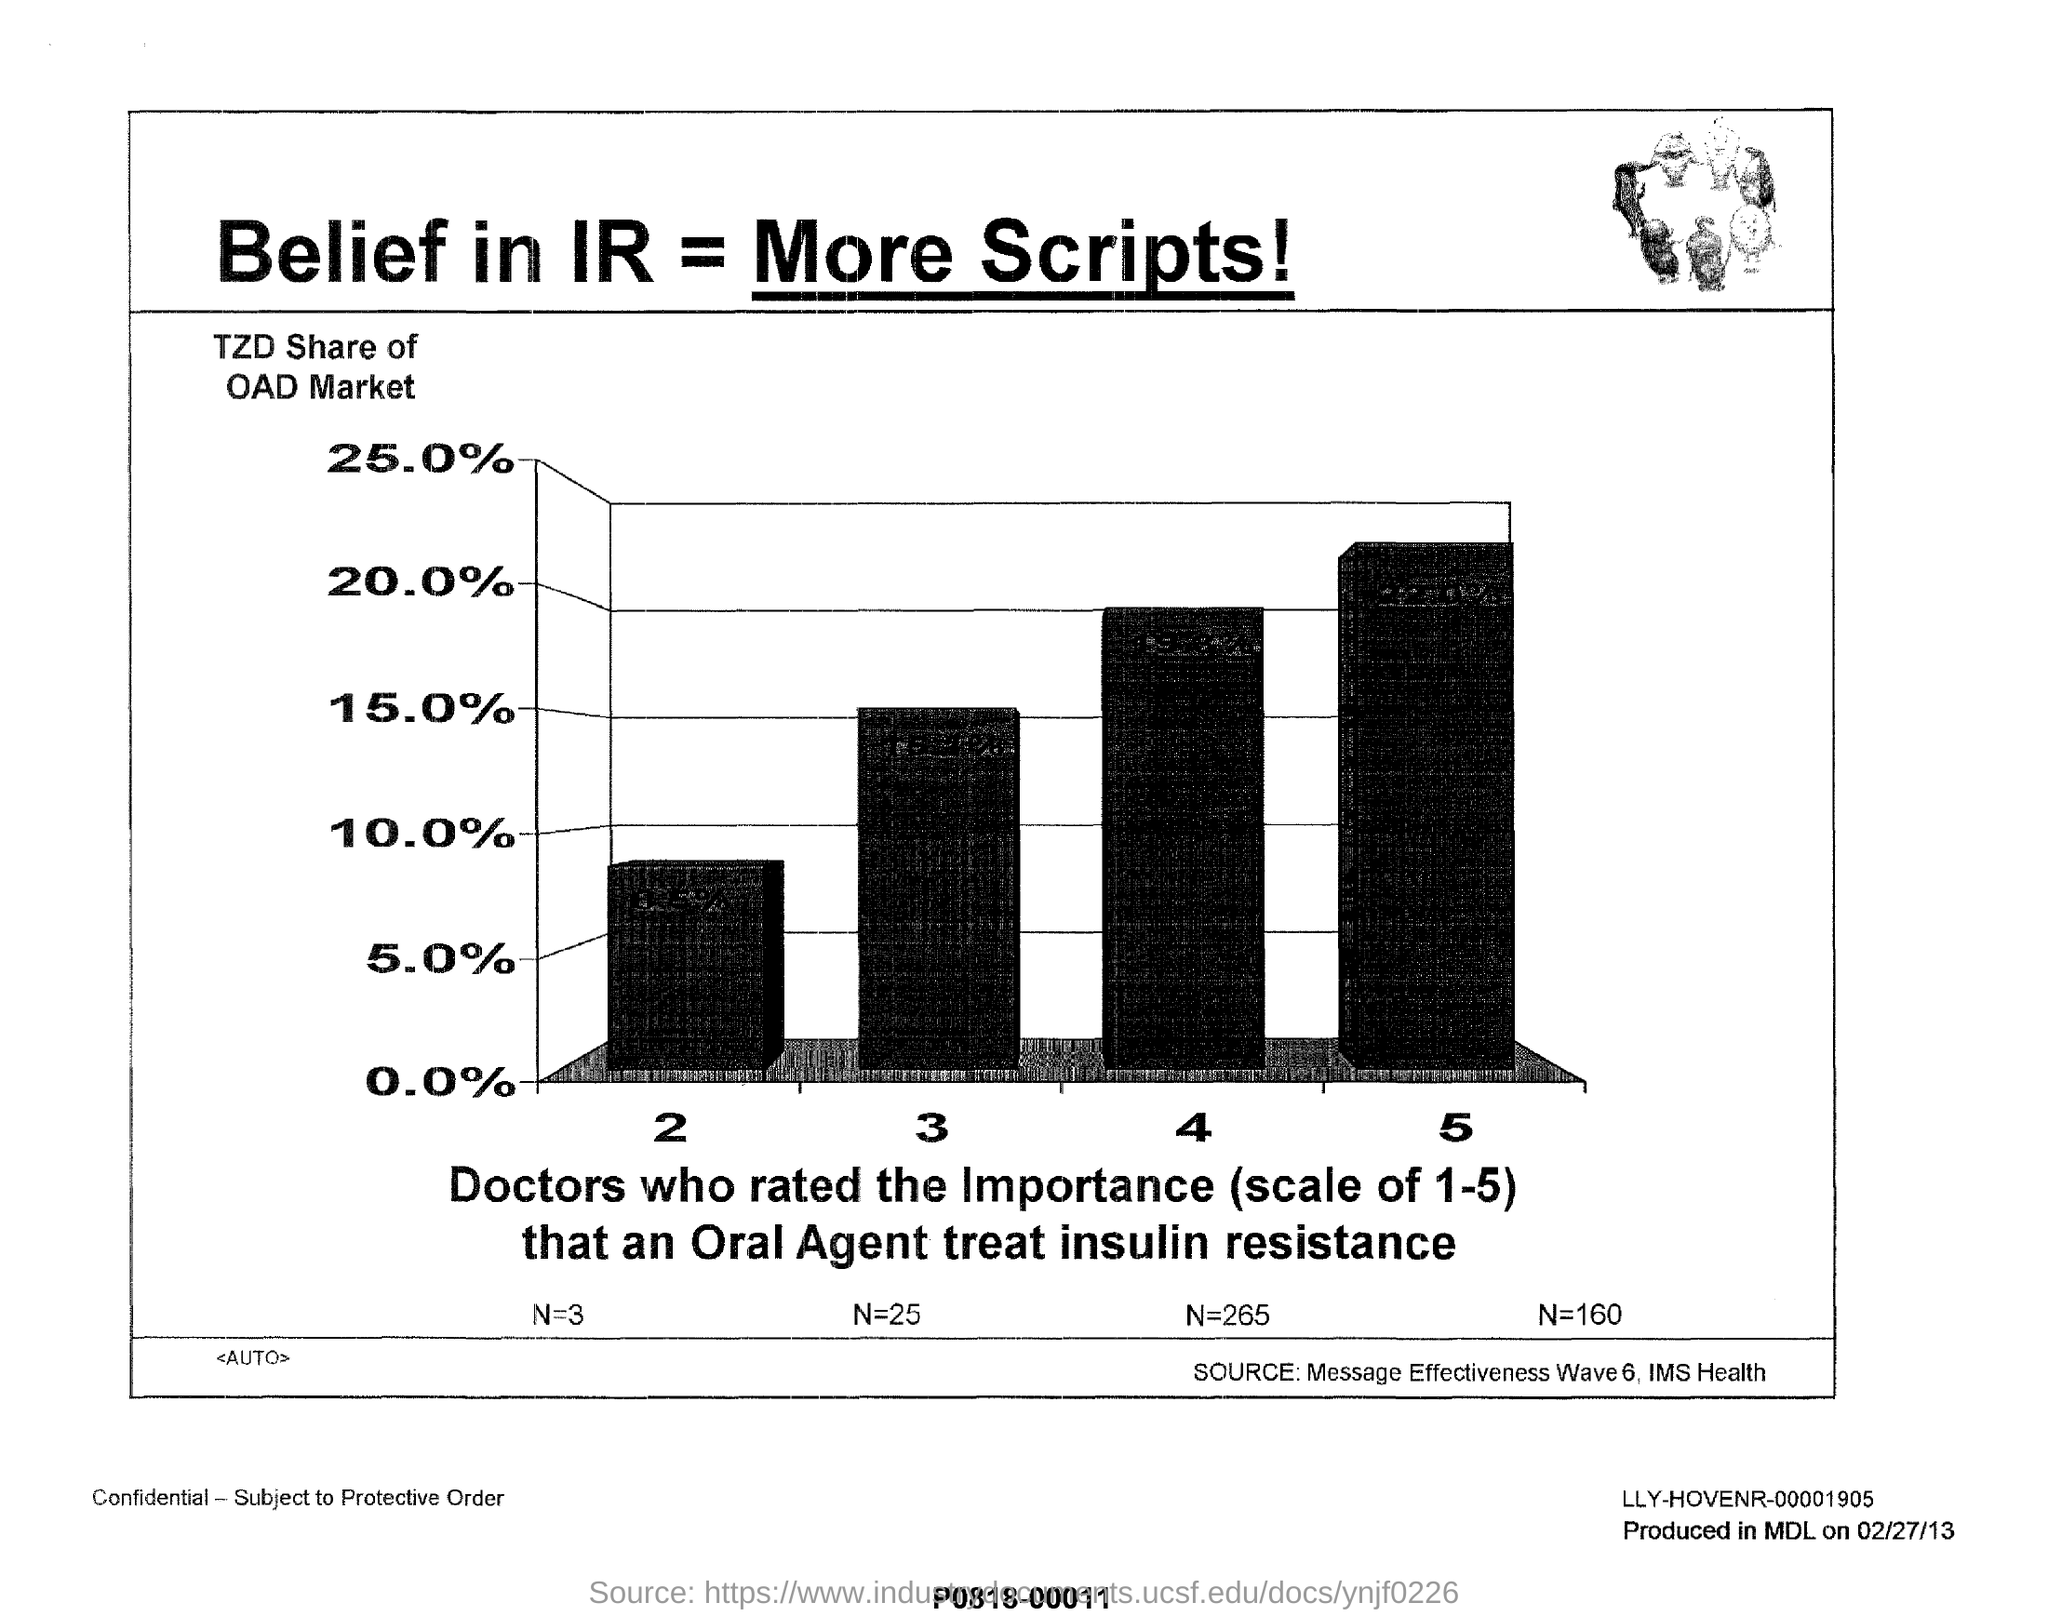List a handful of essential elements in this visual. The Y-axis of the graph represents the TZD share of the OAD market. The TZD share of the OAD market at a scale of 3 is approximately 15%. The TZD share of the OAD market at the scale of 4 is approximately 20%. 